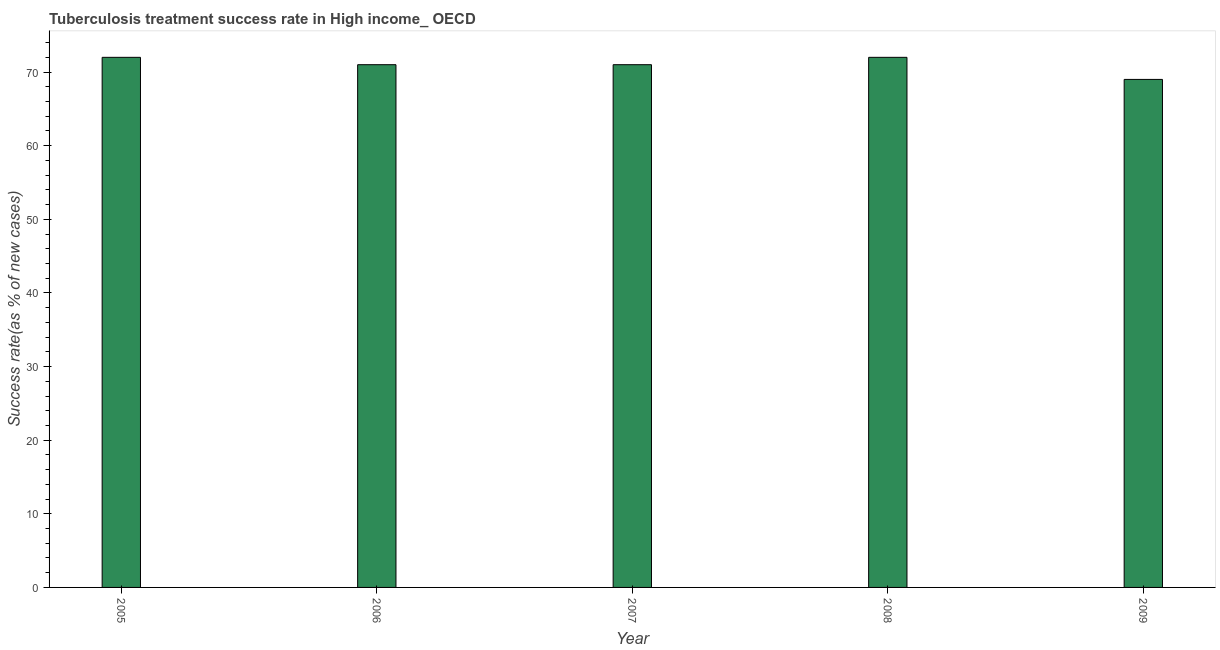Does the graph contain any zero values?
Your response must be concise. No. What is the title of the graph?
Your answer should be very brief. Tuberculosis treatment success rate in High income_ OECD. What is the label or title of the X-axis?
Your answer should be compact. Year. What is the label or title of the Y-axis?
Provide a succinct answer. Success rate(as % of new cases). What is the tuberculosis treatment success rate in 2009?
Provide a succinct answer. 69. Across all years, what is the maximum tuberculosis treatment success rate?
Your response must be concise. 72. Across all years, what is the minimum tuberculosis treatment success rate?
Ensure brevity in your answer.  69. What is the sum of the tuberculosis treatment success rate?
Ensure brevity in your answer.  355. What is the difference between the tuberculosis treatment success rate in 2006 and 2009?
Your response must be concise. 2. What is the median tuberculosis treatment success rate?
Your answer should be compact. 71. What is the ratio of the tuberculosis treatment success rate in 2005 to that in 2009?
Keep it short and to the point. 1.04. What is the difference between the highest and the second highest tuberculosis treatment success rate?
Provide a succinct answer. 0. In how many years, is the tuberculosis treatment success rate greater than the average tuberculosis treatment success rate taken over all years?
Provide a short and direct response. 2. How many bars are there?
Your response must be concise. 5. How many years are there in the graph?
Keep it short and to the point. 5. Are the values on the major ticks of Y-axis written in scientific E-notation?
Keep it short and to the point. No. What is the Success rate(as % of new cases) in 2006?
Ensure brevity in your answer.  71. What is the Success rate(as % of new cases) of 2007?
Give a very brief answer. 71. What is the Success rate(as % of new cases) in 2009?
Keep it short and to the point. 69. What is the difference between the Success rate(as % of new cases) in 2005 and 2006?
Your answer should be compact. 1. What is the difference between the Success rate(as % of new cases) in 2005 and 2008?
Offer a very short reply. 0. What is the difference between the Success rate(as % of new cases) in 2006 and 2007?
Your answer should be compact. 0. What is the difference between the Success rate(as % of new cases) in 2006 and 2008?
Your answer should be compact. -1. What is the ratio of the Success rate(as % of new cases) in 2005 to that in 2007?
Your answer should be compact. 1.01. What is the ratio of the Success rate(as % of new cases) in 2005 to that in 2008?
Offer a terse response. 1. What is the ratio of the Success rate(as % of new cases) in 2005 to that in 2009?
Provide a short and direct response. 1.04. What is the ratio of the Success rate(as % of new cases) in 2006 to that in 2008?
Your answer should be compact. 0.99. What is the ratio of the Success rate(as % of new cases) in 2006 to that in 2009?
Your answer should be very brief. 1.03. What is the ratio of the Success rate(as % of new cases) in 2007 to that in 2009?
Provide a short and direct response. 1.03. What is the ratio of the Success rate(as % of new cases) in 2008 to that in 2009?
Keep it short and to the point. 1.04. 